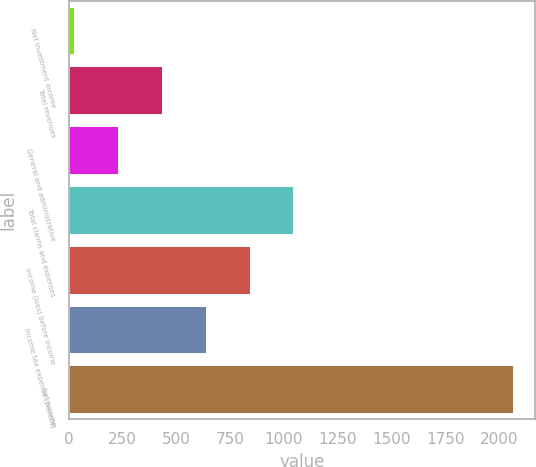<chart> <loc_0><loc_0><loc_500><loc_500><bar_chart><fcel>Net investment income<fcel>Total revenues<fcel>General and administrative<fcel>Total claims and expenses<fcel>Income (loss) before income<fcel>Income tax expense (benefit)<fcel>Net income<nl><fcel>24<fcel>432<fcel>228<fcel>1044<fcel>840<fcel>636<fcel>2064<nl></chart> 